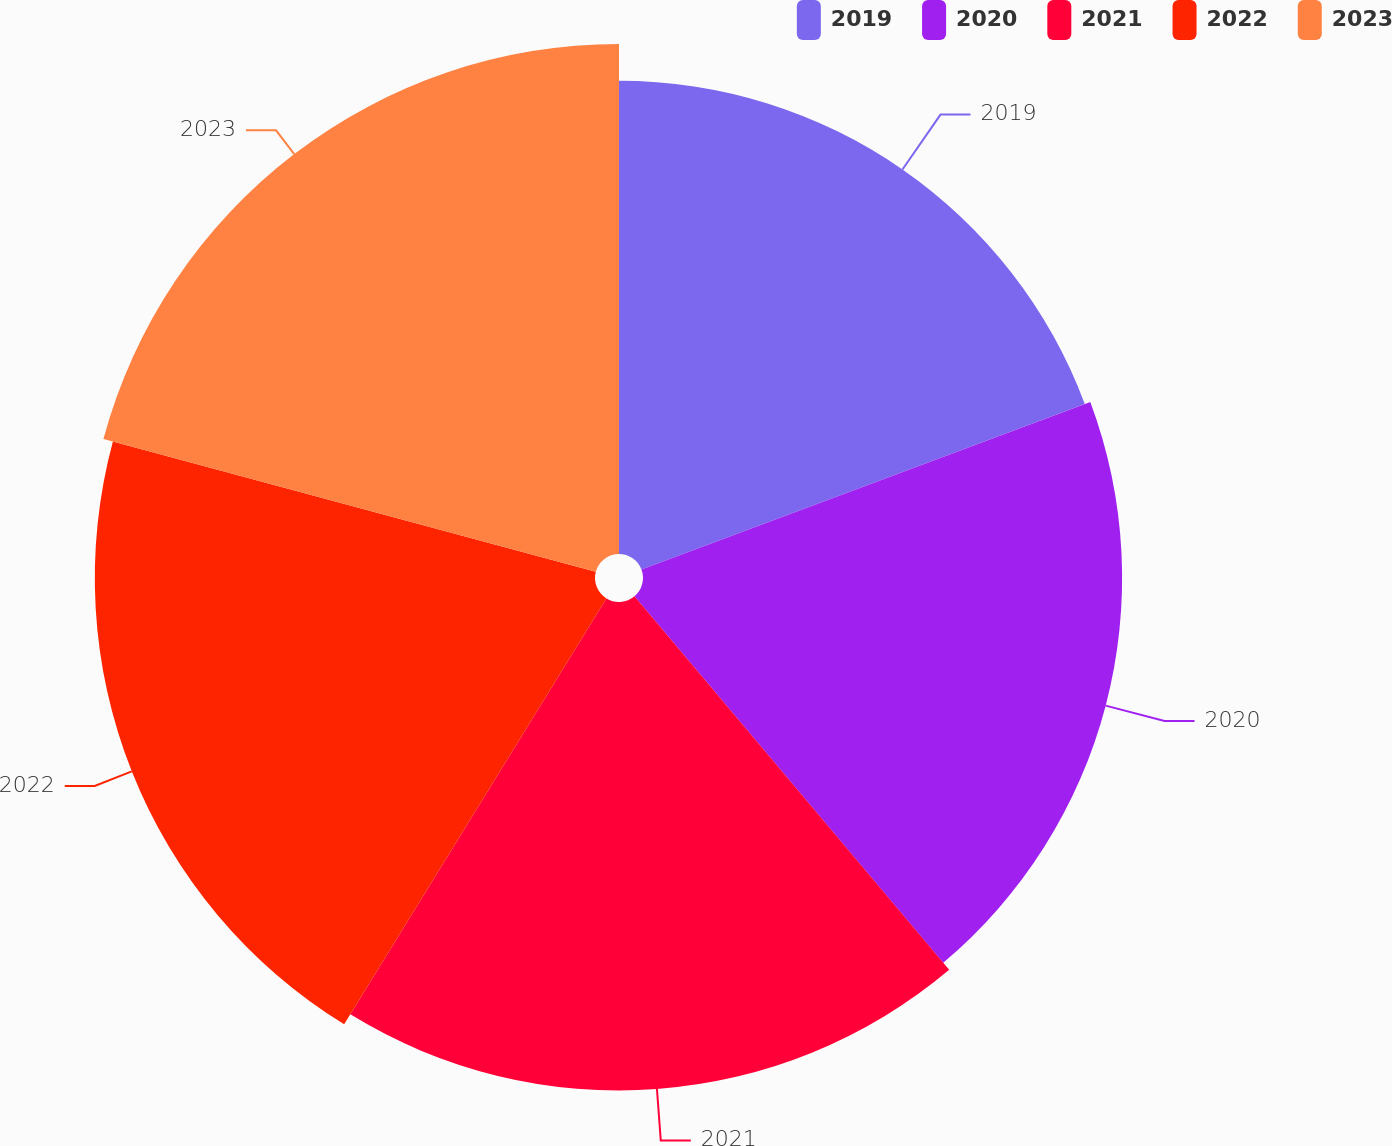Convert chart. <chart><loc_0><loc_0><loc_500><loc_500><pie_chart><fcel>2019<fcel>2020<fcel>2021<fcel>2022<fcel>2023<nl><fcel>19.31%<fcel>19.55%<fcel>19.93%<fcel>20.41%<fcel>20.81%<nl></chart> 